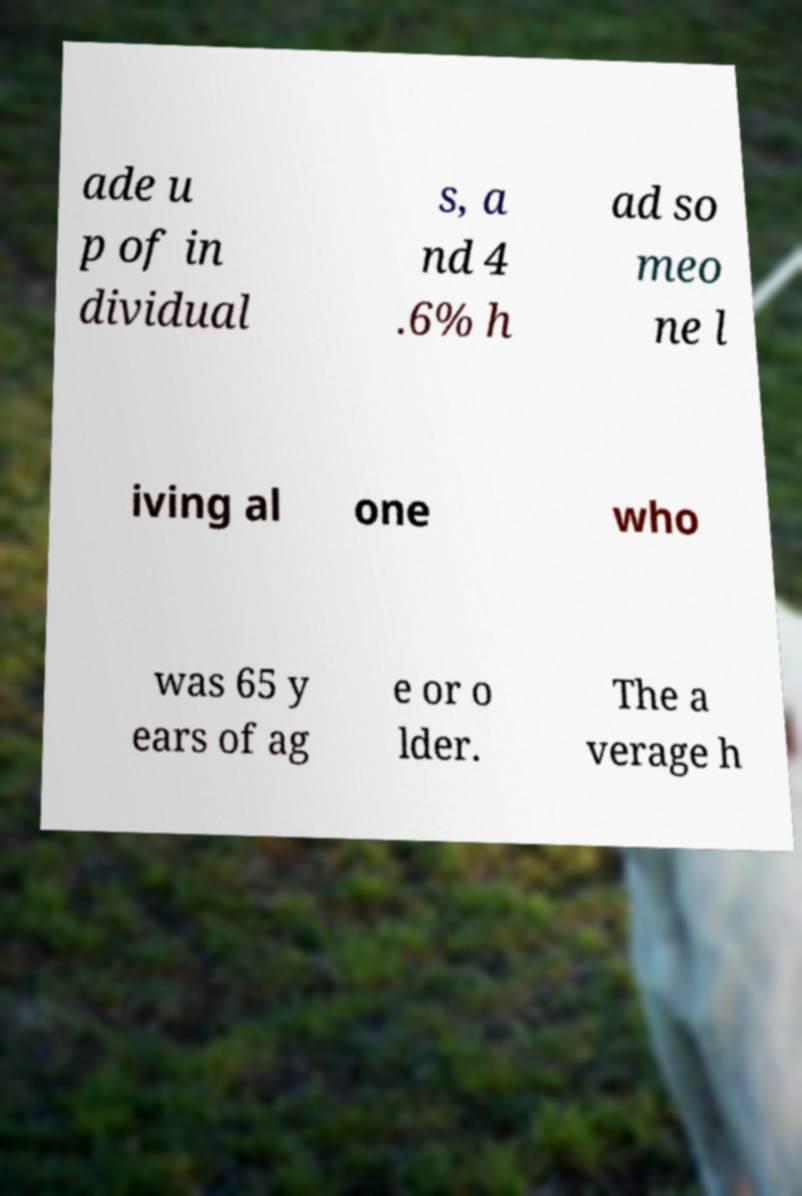For documentation purposes, I need the text within this image transcribed. Could you provide that? ade u p of in dividual s, a nd 4 .6% h ad so meo ne l iving al one who was 65 y ears of ag e or o lder. The a verage h 